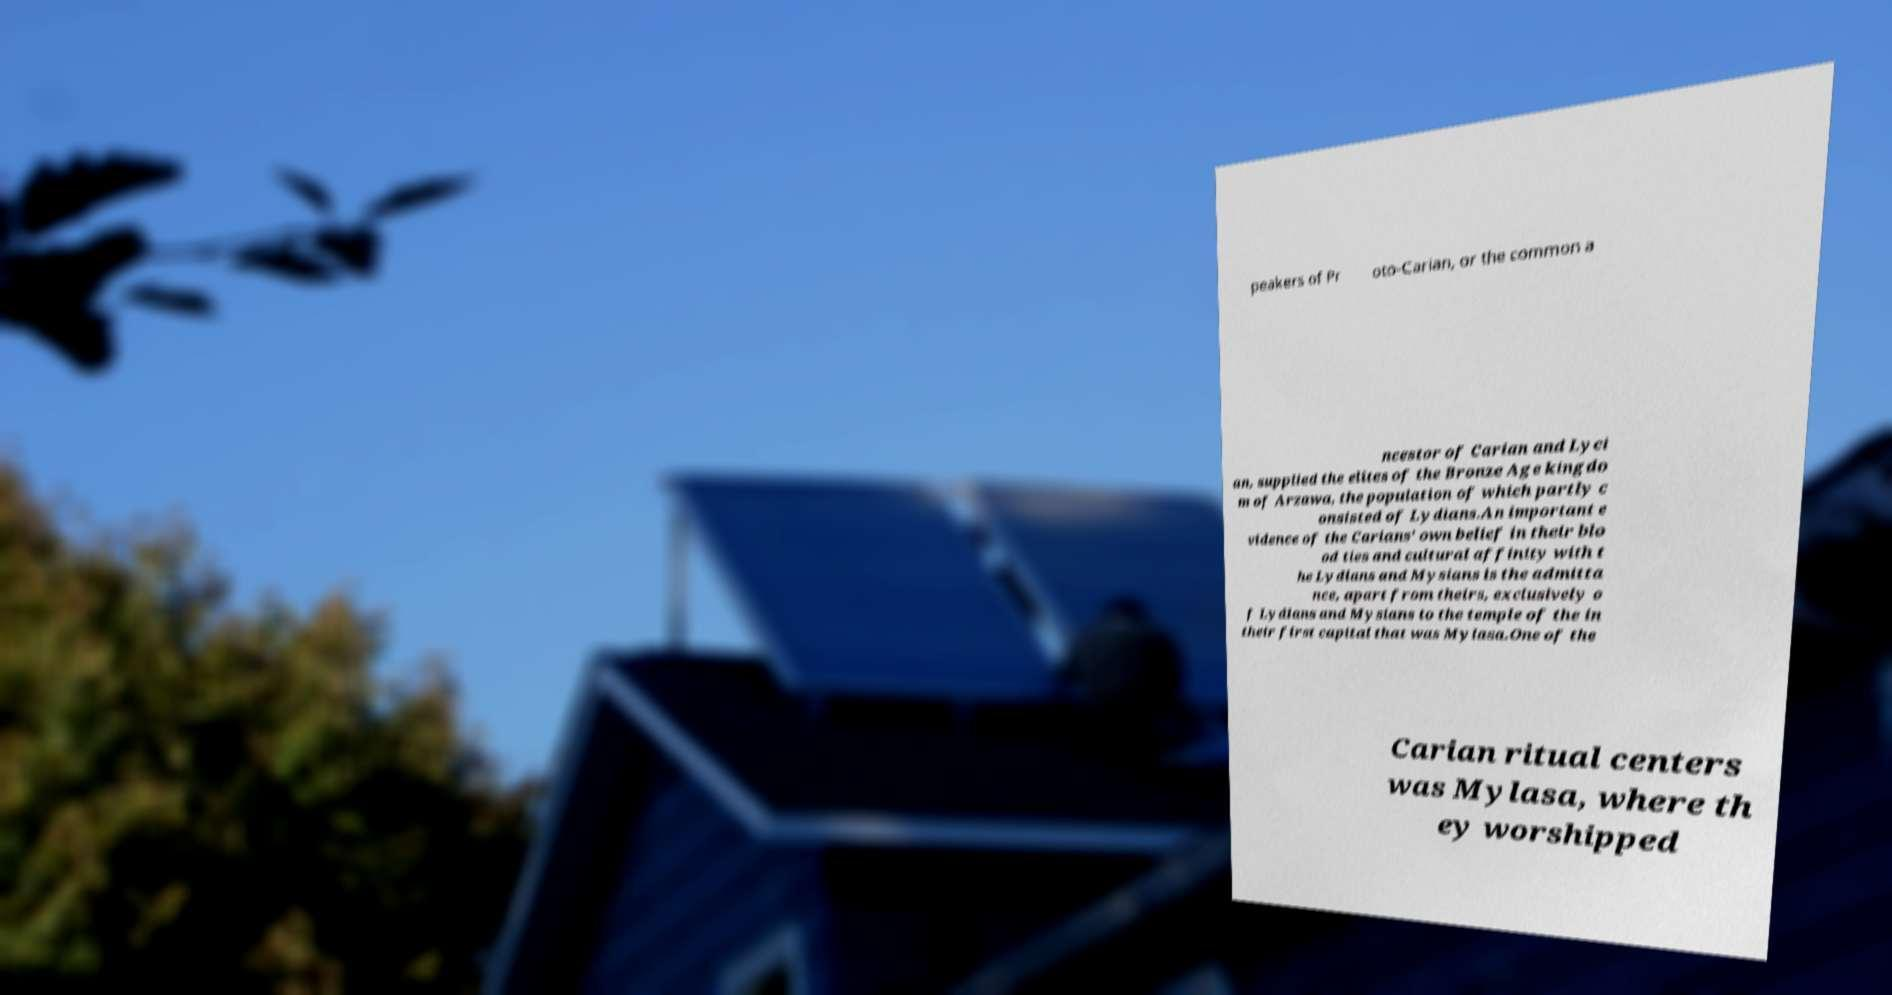Can you read and provide the text displayed in the image?This photo seems to have some interesting text. Can you extract and type it out for me? peakers of Pr oto-Carian, or the common a ncestor of Carian and Lyci an, supplied the elites of the Bronze Age kingdo m of Arzawa, the population of which partly c onsisted of Lydians.An important e vidence of the Carians' own belief in their blo od ties and cultural affinity with t he Lydians and Mysians is the admitta nce, apart from theirs, exclusively o f Lydians and Mysians to the temple of the in their first capital that was Mylasa.One of the Carian ritual centers was Mylasa, where th ey worshipped 